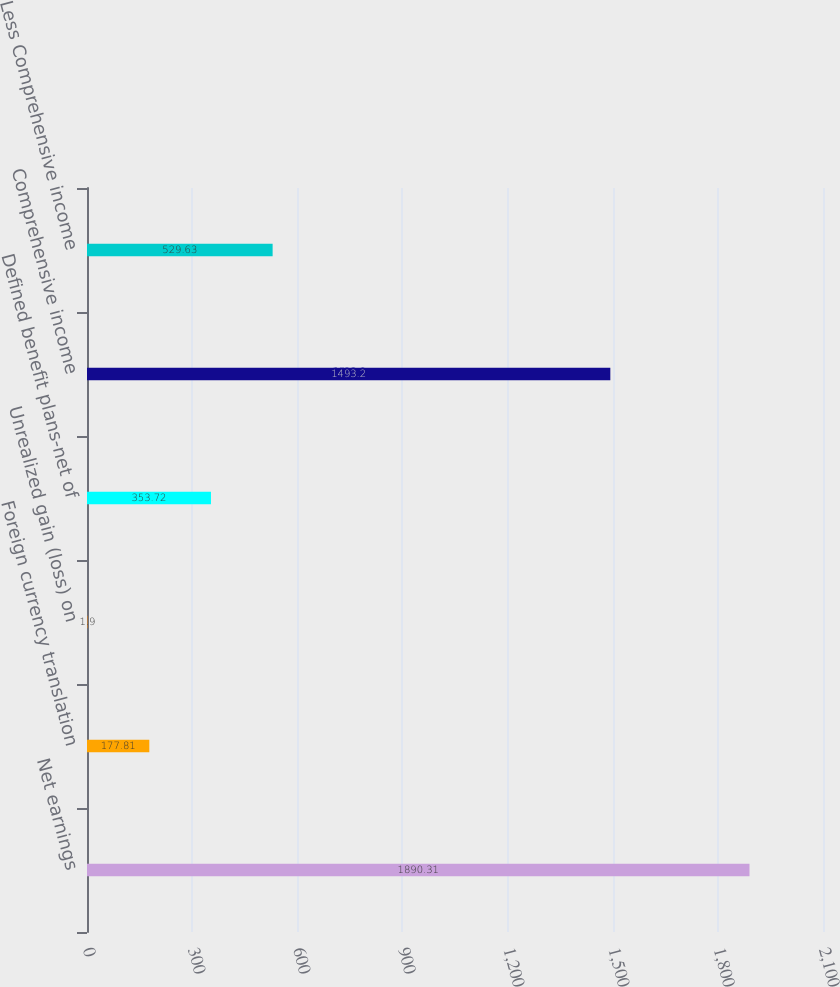<chart> <loc_0><loc_0><loc_500><loc_500><bar_chart><fcel>Net earnings<fcel>Foreign currency translation<fcel>Unrealized gain (loss) on<fcel>Defined benefit plans-net of<fcel>Comprehensive income<fcel>Less Comprehensive income<nl><fcel>1890.31<fcel>177.81<fcel>1.9<fcel>353.72<fcel>1493.2<fcel>529.63<nl></chart> 